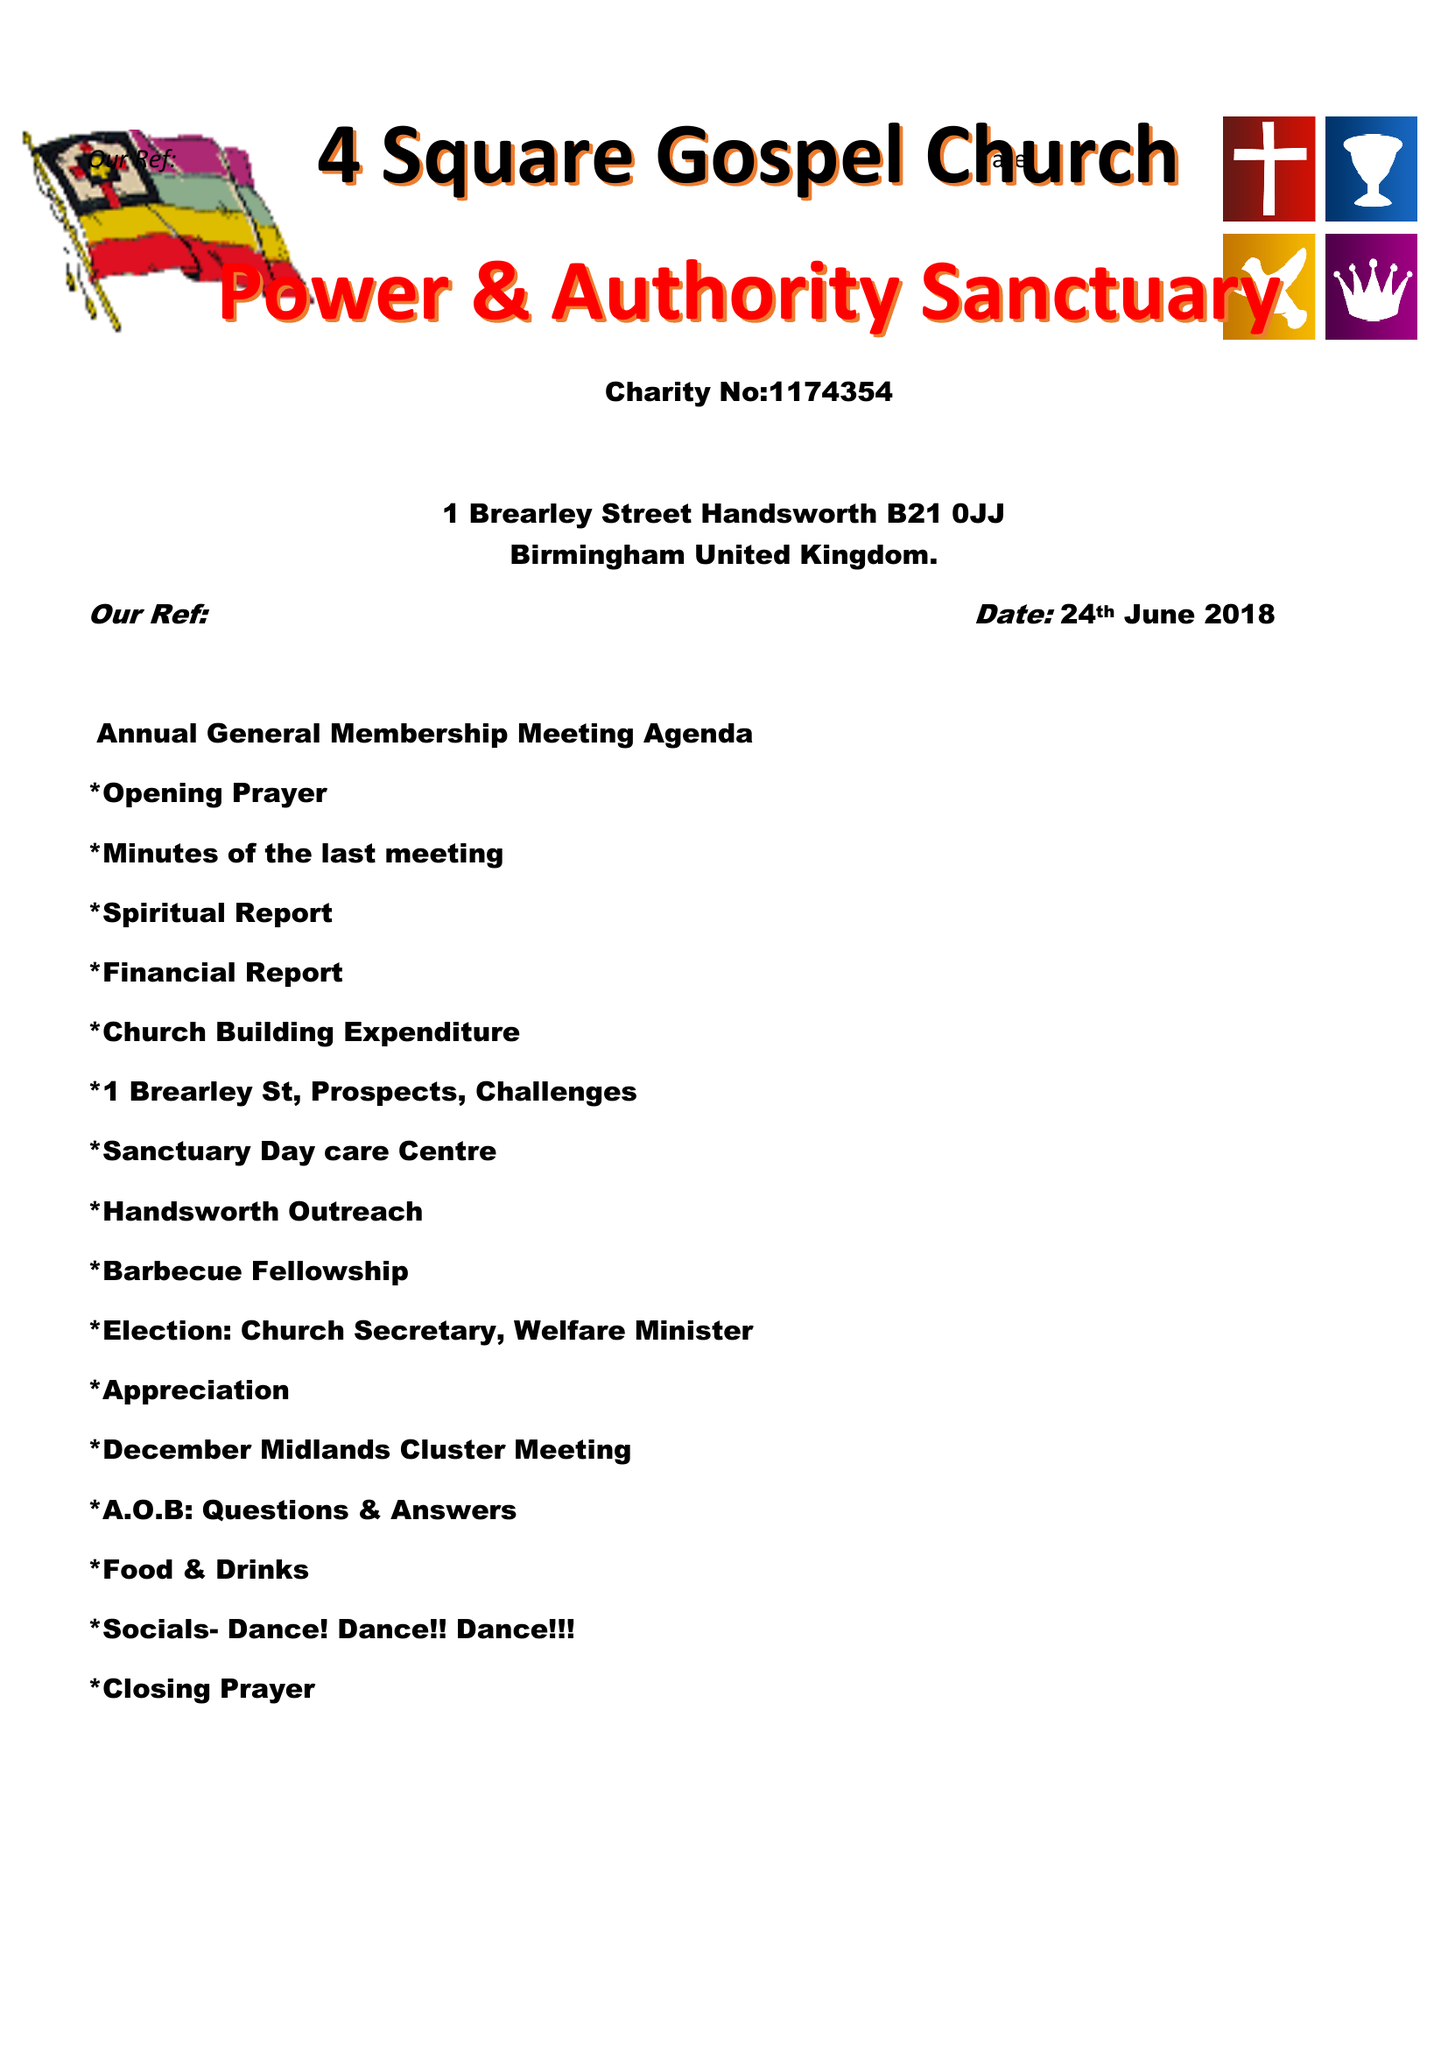What is the value for the address__postcode?
Answer the question using a single word or phrase. B31 1QH 